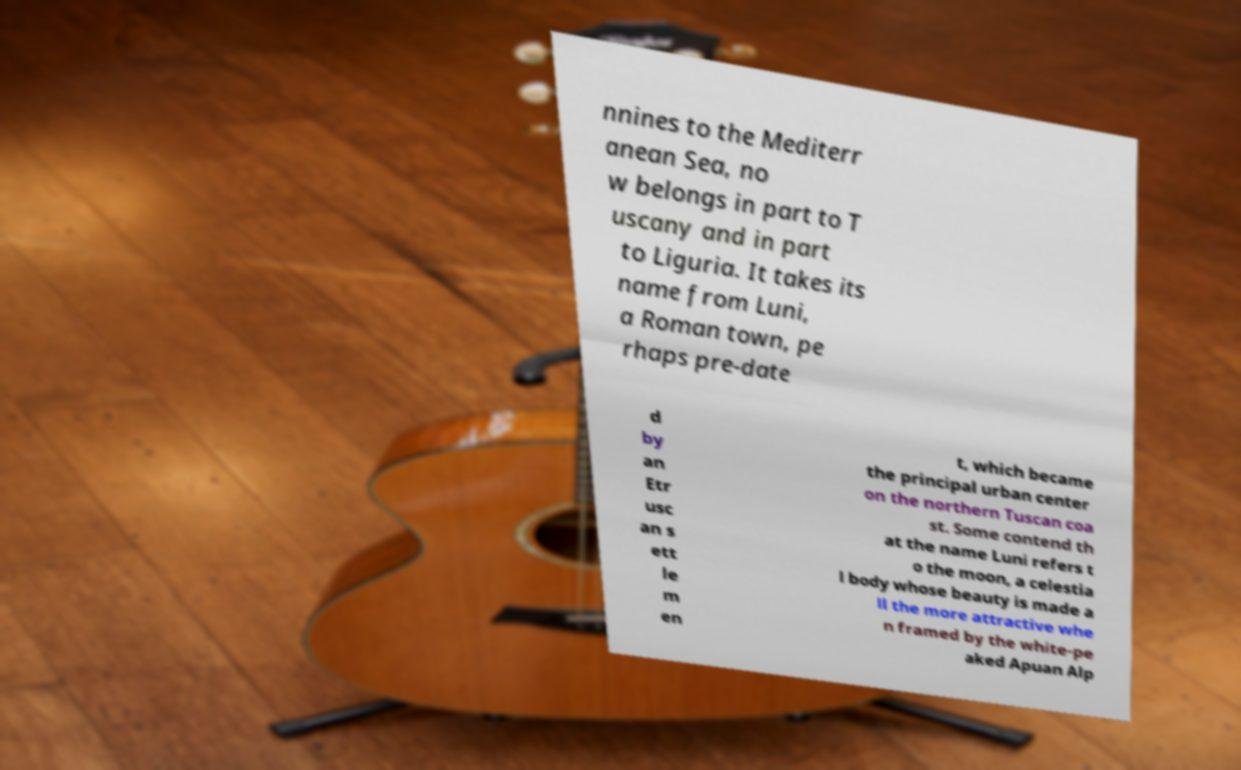Can you read and provide the text displayed in the image?This photo seems to have some interesting text. Can you extract and type it out for me? nnines to the Mediterr anean Sea, no w belongs in part to T uscany and in part to Liguria. It takes its name from Luni, a Roman town, pe rhaps pre-date d by an Etr usc an s ett le m en t, which became the principal urban center on the northern Tuscan coa st. Some contend th at the name Luni refers t o the moon, a celestia l body whose beauty is made a ll the more attractive whe n framed by the white-pe aked Apuan Alp 